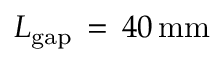Convert formula to latex. <formula><loc_0><loc_0><loc_500><loc_500>L _ { g a p } \, = \, 4 0 \, { m m }</formula> 